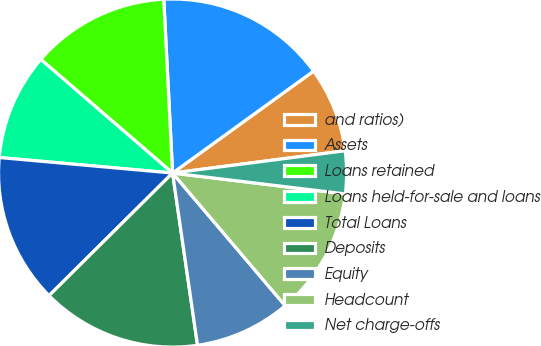<chart> <loc_0><loc_0><loc_500><loc_500><pie_chart><fcel>and ratios)<fcel>Assets<fcel>Loans retained<fcel>Loans held-for-sale and loans<fcel>Total Loans<fcel>Deposits<fcel>Equity<fcel>Headcount<fcel>Net charge-offs<nl><fcel>7.92%<fcel>15.84%<fcel>12.87%<fcel>9.9%<fcel>13.86%<fcel>14.85%<fcel>8.91%<fcel>11.88%<fcel>3.96%<nl></chart> 